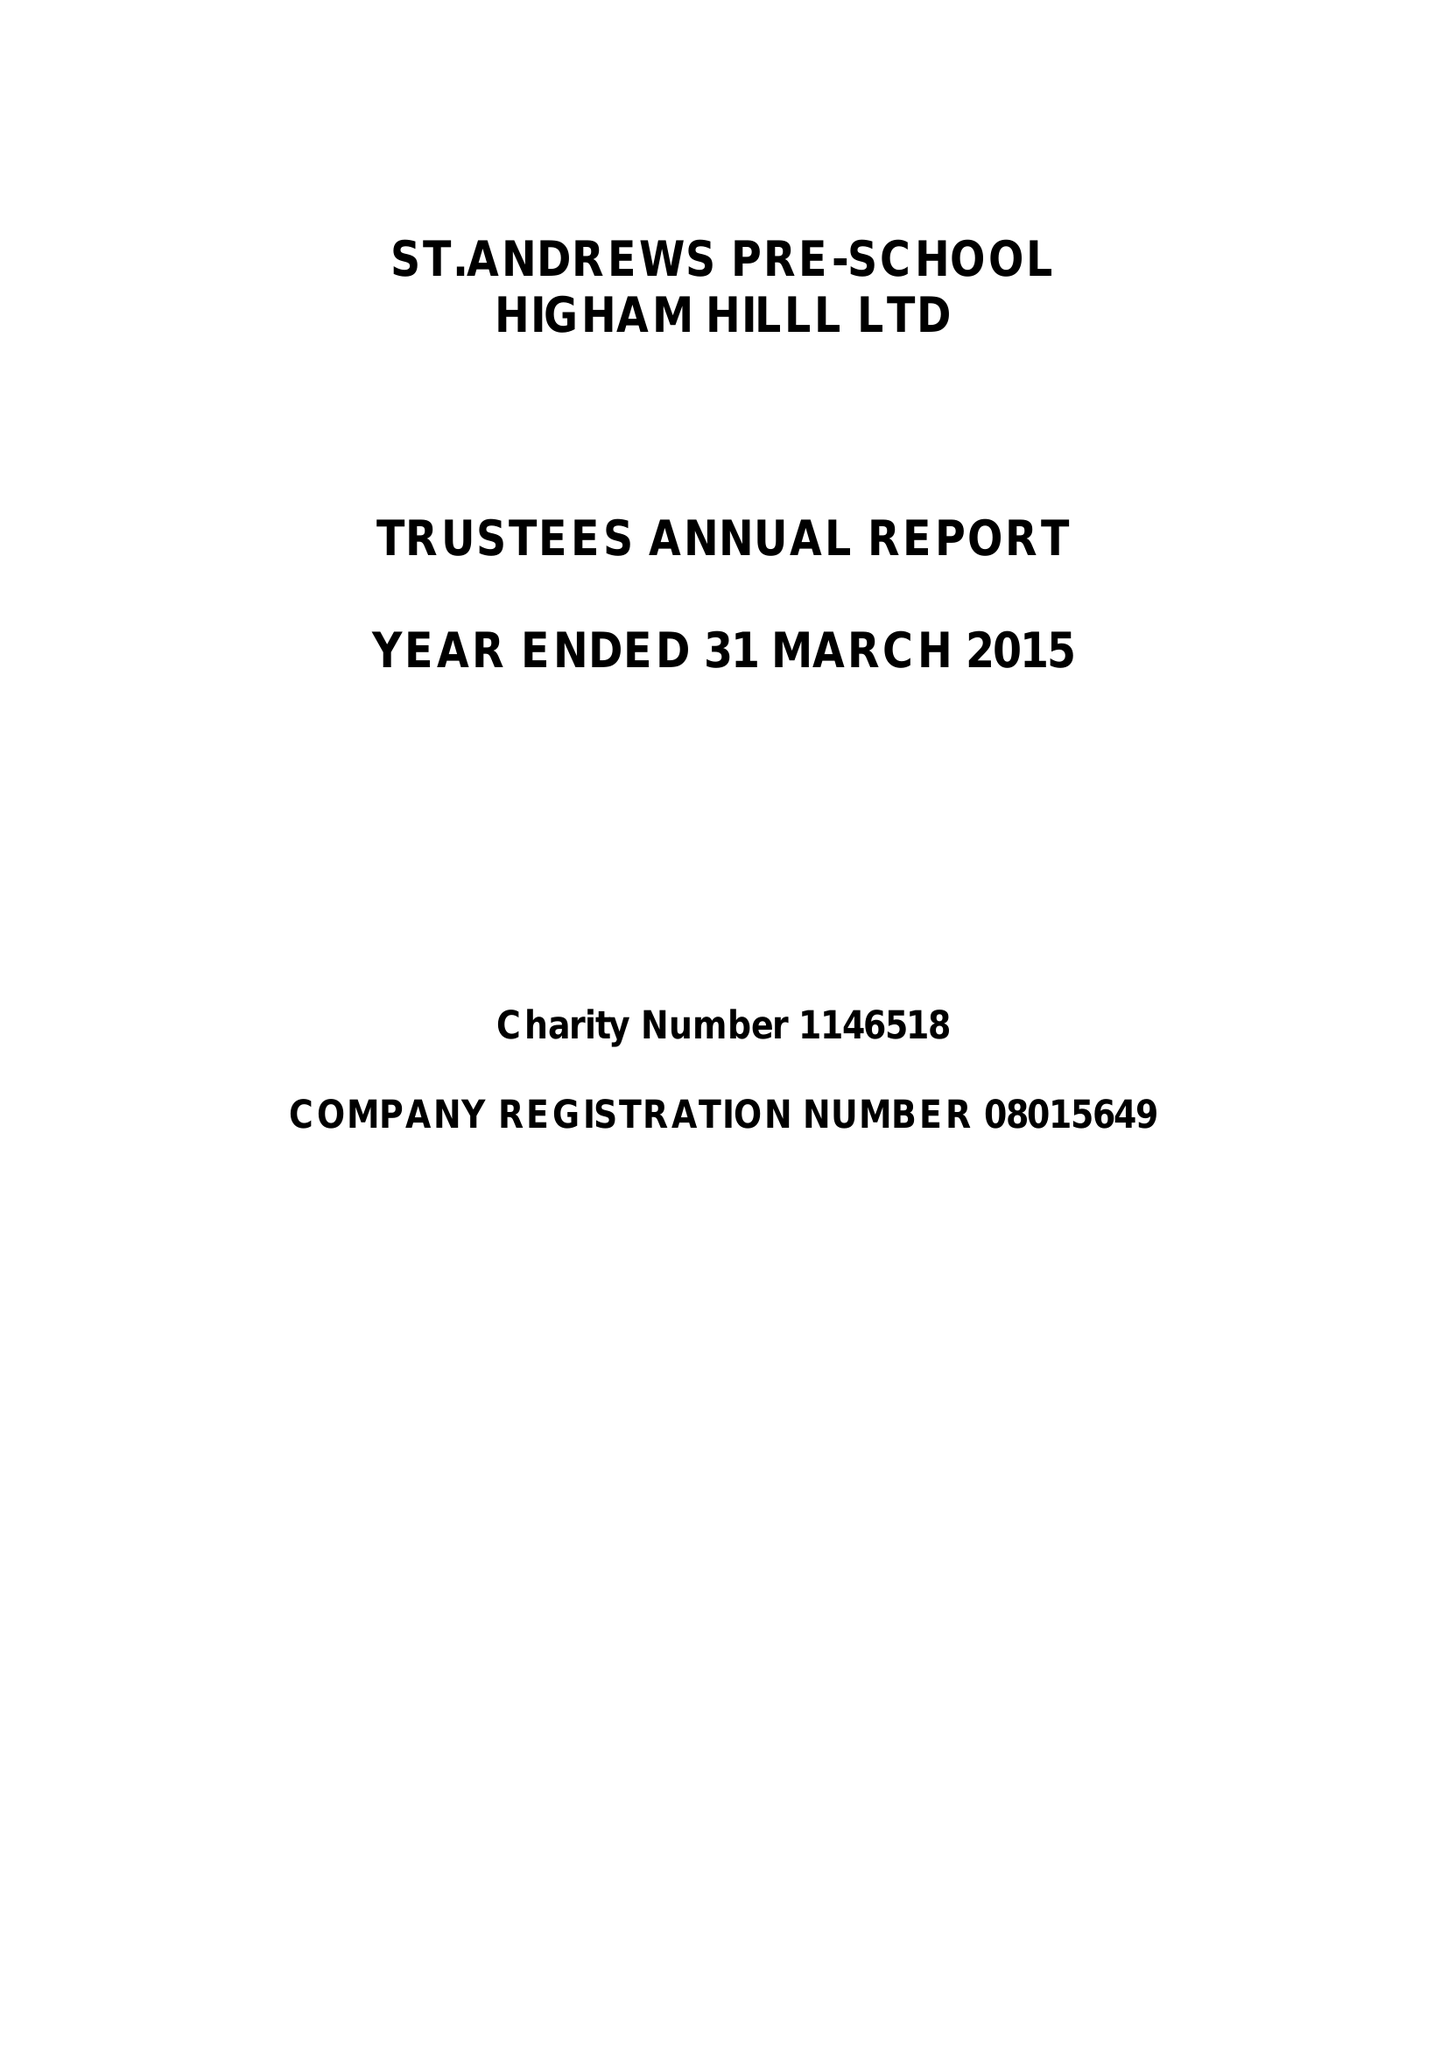What is the value for the income_annually_in_british_pounds?
Answer the question using a single word or phrase. 108322.00 